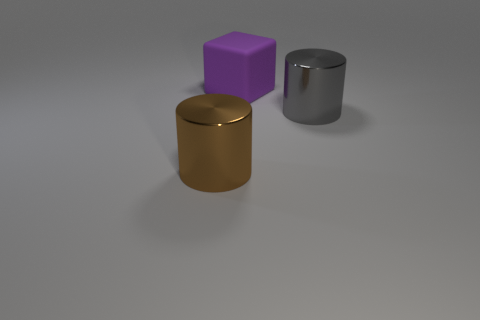Considering the lighting in the scene, what time of day do you think it is, or is the lighting artificial? Since the lighting in the scene does not show any identifiable natural light sources such as a sun, and the shadows are soft and diffuse, it is likely that the lighting is artificial. This could be an indoor setting with controlled lighting conditions. 